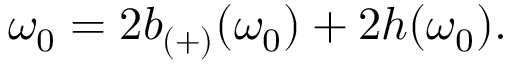Convert formula to latex. <formula><loc_0><loc_0><loc_500><loc_500>\omega _ { 0 } = 2 b _ { ( + ) } ( \omega _ { 0 } ) + 2 h ( \omega _ { 0 } ) .</formula> 